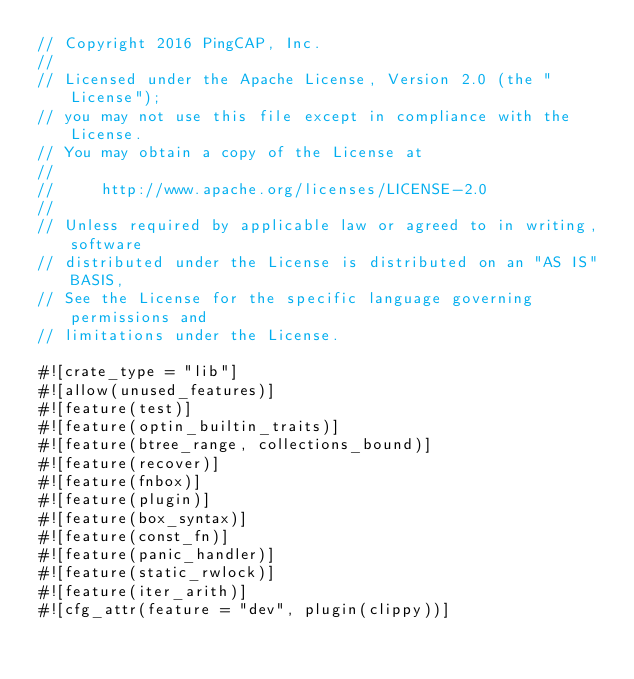Convert code to text. <code><loc_0><loc_0><loc_500><loc_500><_Rust_>// Copyright 2016 PingCAP, Inc.
//
// Licensed under the Apache License, Version 2.0 (the "License");
// you may not use this file except in compliance with the License.
// You may obtain a copy of the License at
//
//     http://www.apache.org/licenses/LICENSE-2.0
//
// Unless required by applicable law or agreed to in writing, software
// distributed under the License is distributed on an "AS IS" BASIS,
// See the License for the specific language governing permissions and
// limitations under the License.

#![crate_type = "lib"]
#![allow(unused_features)]
#![feature(test)]
#![feature(optin_builtin_traits)]
#![feature(btree_range, collections_bound)]
#![feature(recover)]
#![feature(fnbox)]
#![feature(plugin)]
#![feature(box_syntax)]
#![feature(const_fn)]
#![feature(panic_handler)]
#![feature(static_rwlock)]
#![feature(iter_arith)]
#![cfg_attr(feature = "dev", plugin(clippy))]</code> 